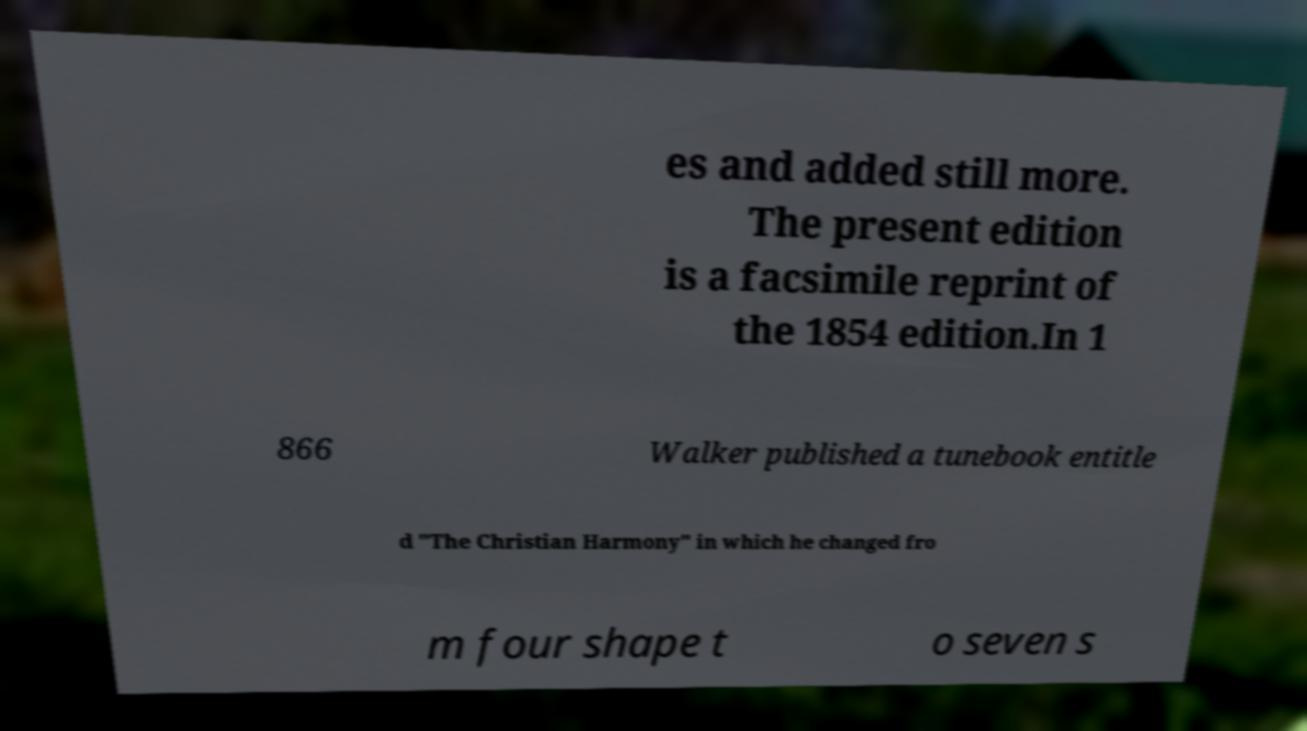Please identify and transcribe the text found in this image. es and added still more. The present edition is a facsimile reprint of the 1854 edition.In 1 866 Walker published a tunebook entitle d "The Christian Harmony" in which he changed fro m four shape t o seven s 